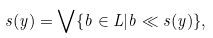Convert formula to latex. <formula><loc_0><loc_0><loc_500><loc_500>s ( y ) = \bigvee \{ b \in L | b \ll s ( y ) \} ,</formula> 